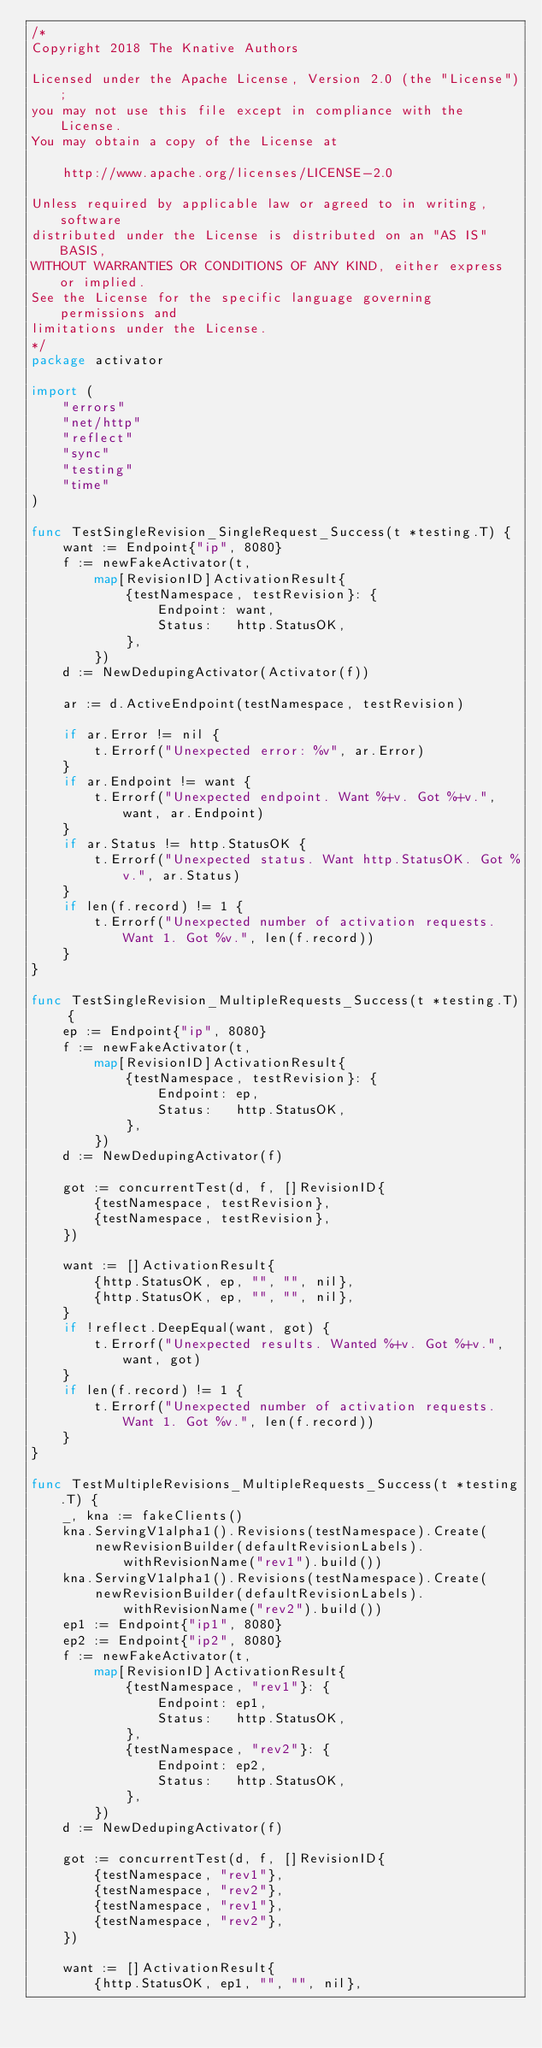Convert code to text. <code><loc_0><loc_0><loc_500><loc_500><_Go_>/*
Copyright 2018 The Knative Authors

Licensed under the Apache License, Version 2.0 (the "License");
you may not use this file except in compliance with the License.
You may obtain a copy of the License at

    http://www.apache.org/licenses/LICENSE-2.0

Unless required by applicable law or agreed to in writing, software
distributed under the License is distributed on an "AS IS" BASIS,
WITHOUT WARRANTIES OR CONDITIONS OF ANY KIND, either express or implied.
See the License for the specific language governing permissions and
limitations under the License.
*/
package activator

import (
	"errors"
	"net/http"
	"reflect"
	"sync"
	"testing"
	"time"
)

func TestSingleRevision_SingleRequest_Success(t *testing.T) {
	want := Endpoint{"ip", 8080}
	f := newFakeActivator(t,
		map[RevisionID]ActivationResult{
			{testNamespace, testRevision}: {
				Endpoint: want,
				Status:   http.StatusOK,
			},
		})
	d := NewDedupingActivator(Activator(f))

	ar := d.ActiveEndpoint(testNamespace, testRevision)

	if ar.Error != nil {
		t.Errorf("Unexpected error: %v", ar.Error)
	}
	if ar.Endpoint != want {
		t.Errorf("Unexpected endpoint. Want %+v. Got %+v.", want, ar.Endpoint)
	}
	if ar.Status != http.StatusOK {
		t.Errorf("Unexpected status. Want http.StatusOK. Got %v.", ar.Status)
	}
	if len(f.record) != 1 {
		t.Errorf("Unexpected number of activation requests. Want 1. Got %v.", len(f.record))
	}
}

func TestSingleRevision_MultipleRequests_Success(t *testing.T) {
	ep := Endpoint{"ip", 8080}
	f := newFakeActivator(t,
		map[RevisionID]ActivationResult{
			{testNamespace, testRevision}: {
				Endpoint: ep,
				Status:   http.StatusOK,
			},
		})
	d := NewDedupingActivator(f)

	got := concurrentTest(d, f, []RevisionID{
		{testNamespace, testRevision},
		{testNamespace, testRevision},
	})

	want := []ActivationResult{
		{http.StatusOK, ep, "", "", nil},
		{http.StatusOK, ep, "", "", nil},
	}
	if !reflect.DeepEqual(want, got) {
		t.Errorf("Unexpected results. Wanted %+v. Got %+v.", want, got)
	}
	if len(f.record) != 1 {
		t.Errorf("Unexpected number of activation requests. Want 1. Got %v.", len(f.record))
	}
}

func TestMultipleRevisions_MultipleRequests_Success(t *testing.T) {
	_, kna := fakeClients()
	kna.ServingV1alpha1().Revisions(testNamespace).Create(
		newRevisionBuilder(defaultRevisionLabels).withRevisionName("rev1").build())
	kna.ServingV1alpha1().Revisions(testNamespace).Create(
		newRevisionBuilder(defaultRevisionLabels).withRevisionName("rev2").build())
	ep1 := Endpoint{"ip1", 8080}
	ep2 := Endpoint{"ip2", 8080}
	f := newFakeActivator(t,
		map[RevisionID]ActivationResult{
			{testNamespace, "rev1"}: {
				Endpoint: ep1,
				Status:   http.StatusOK,
			},
			{testNamespace, "rev2"}: {
				Endpoint: ep2,
				Status:   http.StatusOK,
			},
		})
	d := NewDedupingActivator(f)

	got := concurrentTest(d, f, []RevisionID{
		{testNamespace, "rev1"},
		{testNamespace, "rev2"},
		{testNamespace, "rev1"},
		{testNamespace, "rev2"},
	})

	want := []ActivationResult{
		{http.StatusOK, ep1, "", "", nil},</code> 